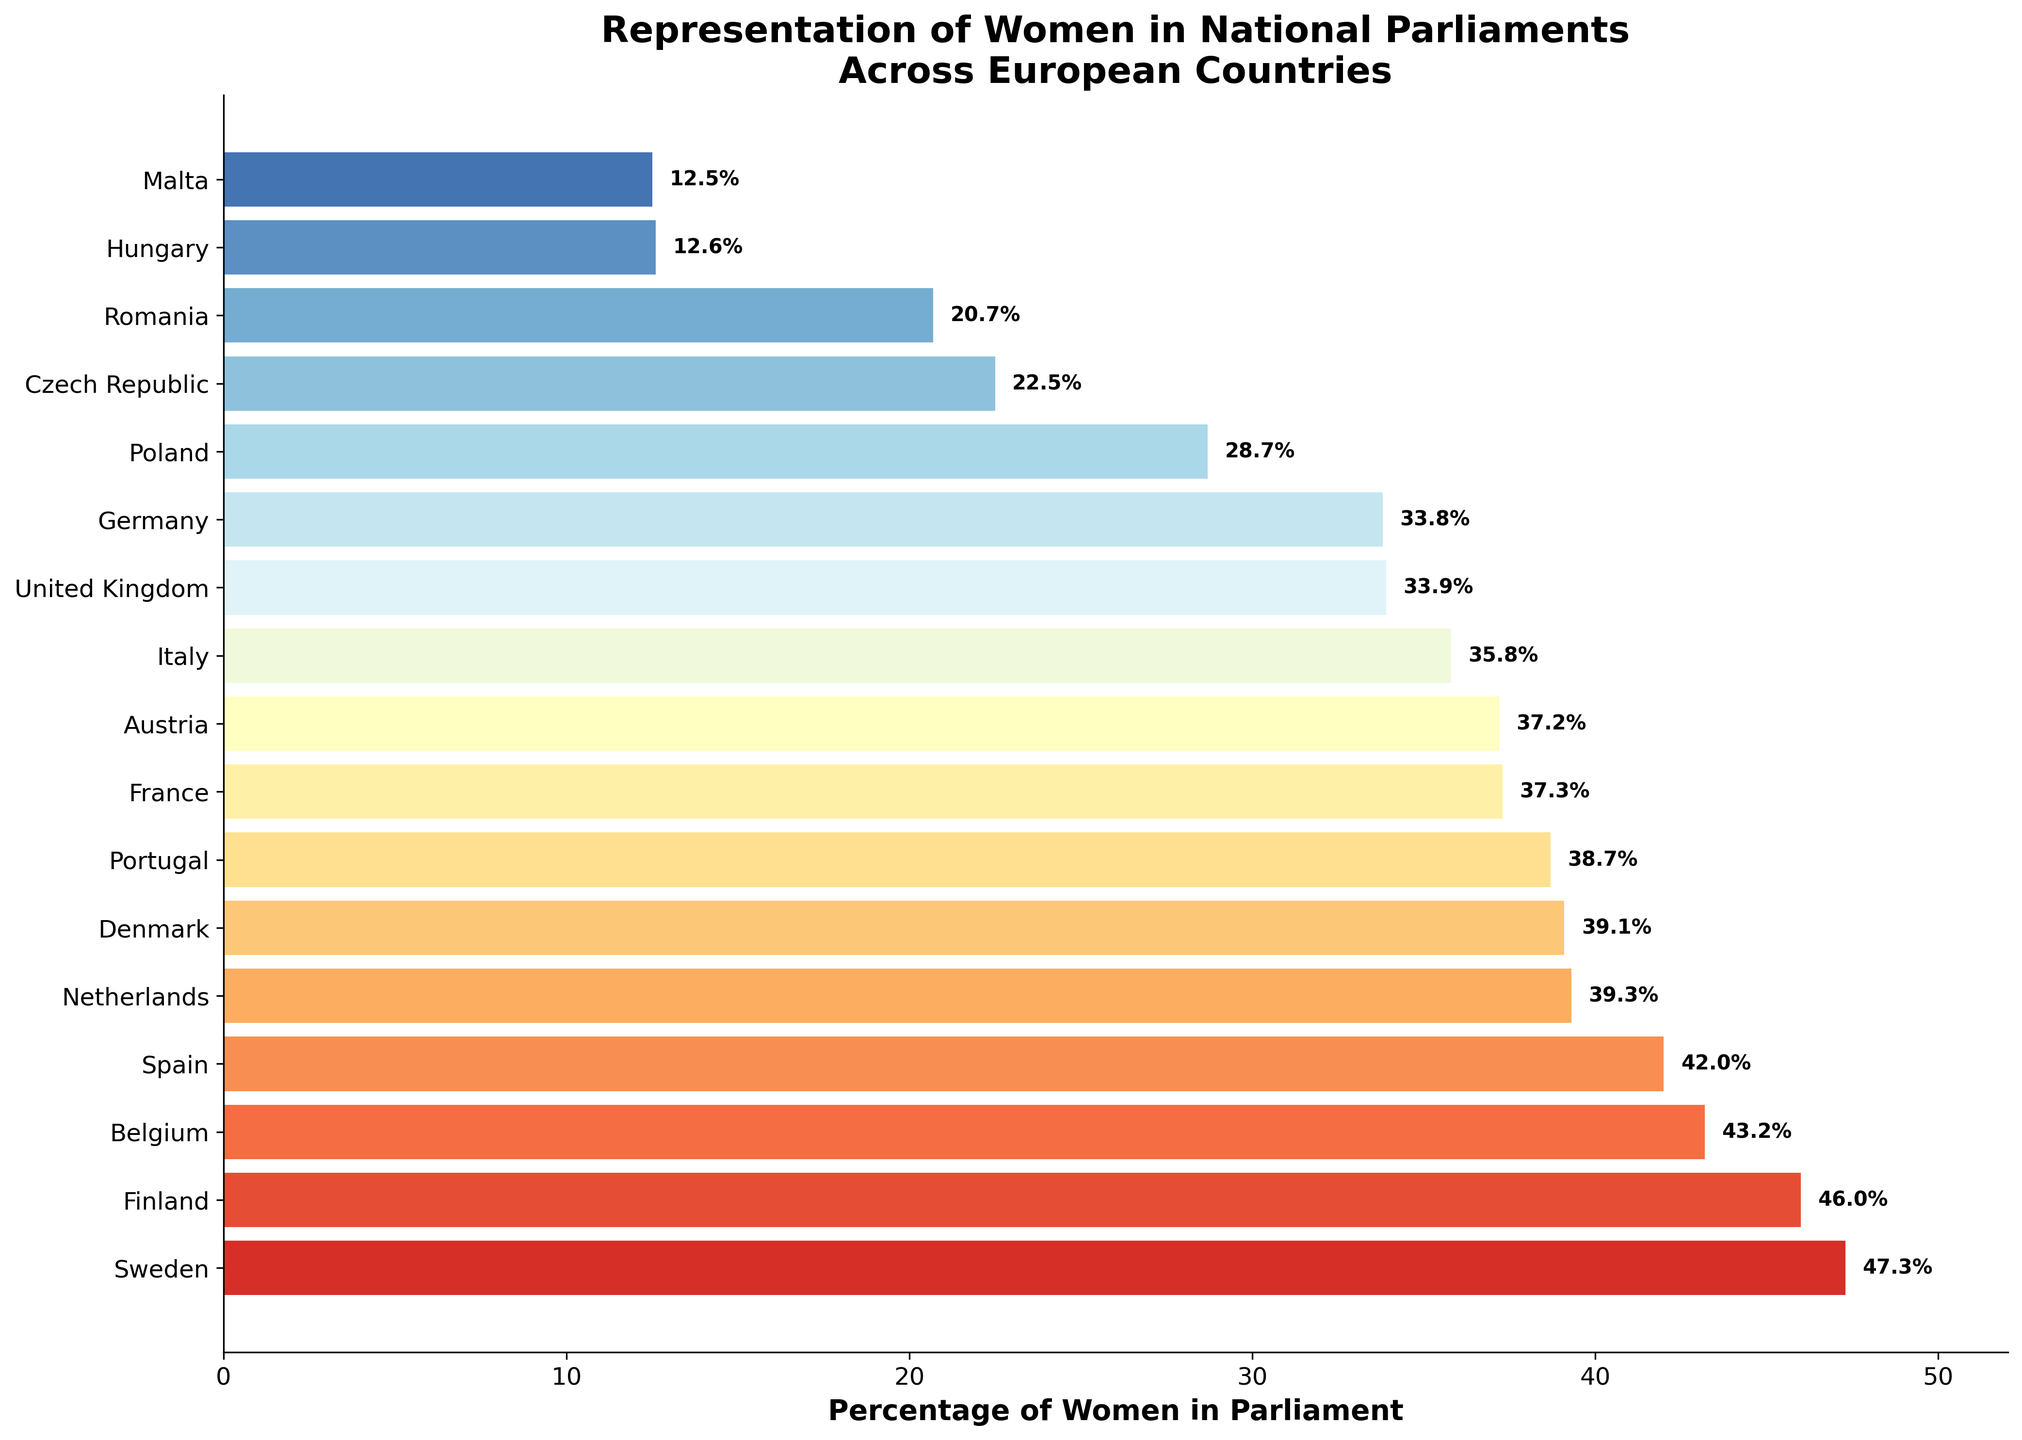Which country has the highest percentage of women in parliament? By looking at the bar chart, we can see the country with the longest bar, which represents the highest percentage. The longest bar corresponds to Sweden.
Answer: Sweden What is the percentage point difference between the Netherlands and Denmark in women’s representation in parliament? We observe the bars for both Netherlands and Denmark and subtract the percentage of Denmark from that of Netherlands. The Netherlands has 39.3% and Denmark has 39.1%, so the difference is 39.3 - 39.1 = 0.2.
Answer: 0.2 Which countries have less than 25% women representation in their parliaments? We examine the bars representing the percentages for each country and identify those with bars shorter than the 25% mark. By doing so, we find that Czech Republic, Romania, Hungary, and Malta have less than 25%.
Answer: Czech Republic, Romania, Hungary, Malta What is the average percentage of women representation in the top three countries? The top three countries are Sweden, Finland, and Belgium with percentages of 47.3, 46.0, and 43.2 respectively. To find the average, we add these percentages and divide by 3. (47.3 + 46.0 + 43.2) / 3 = 45.5.
Answer: 45.5 How many countries have more than 40% women representation in parliament? We count the number of bars that extend beyond the 40% mark on the horizontal axis. From the figure, Sweden, Finland, Belgium, and Spain exceed 40%. This gives a total of 4 countries.
Answer: 4 Between Belgium and Portugal, which country has higher women representation in parliament and by how much? By examining the bars for Belgium and Portugal, Belgium has 43.2% and Portugal has 38.7%. Subtracting these gives the difference: 43.2 - 38.7 = 4.5, and the higher percentage is with Belgium.
Answer: Belgium, 4.5 Considering Germany and the United Kingdom, which country has a lower percentage of women in parliament and what is the percentage point difference? Observing the bars for both Germany and the United Kingdom, Germany has 33.8% and the United Kingdom has 33.9%. Subtracting these gives the difference: 33.9 - 33.8 = 0.1. Germany has a lower percentage.
Answer: Germany, 0.1 Rank the following countries from highest to lowest in terms of women representation in parliament: France, Austria, and Italy. By looking at the bars corresponding to these countries, we see France has 37.3%, Austria has 37.2%, and Italy has 35.8%. Ordered from highest to lowest, we get France, Austria, and then Italy.
Answer: France, Austria, Italy What’s the total percentage of women representation in parliament for Sweden and Finland combined? Adding the percentages for Sweden and Finland gives us the sum: 47.3% + 46.0% = 93.3%.
Answer: 93.3 